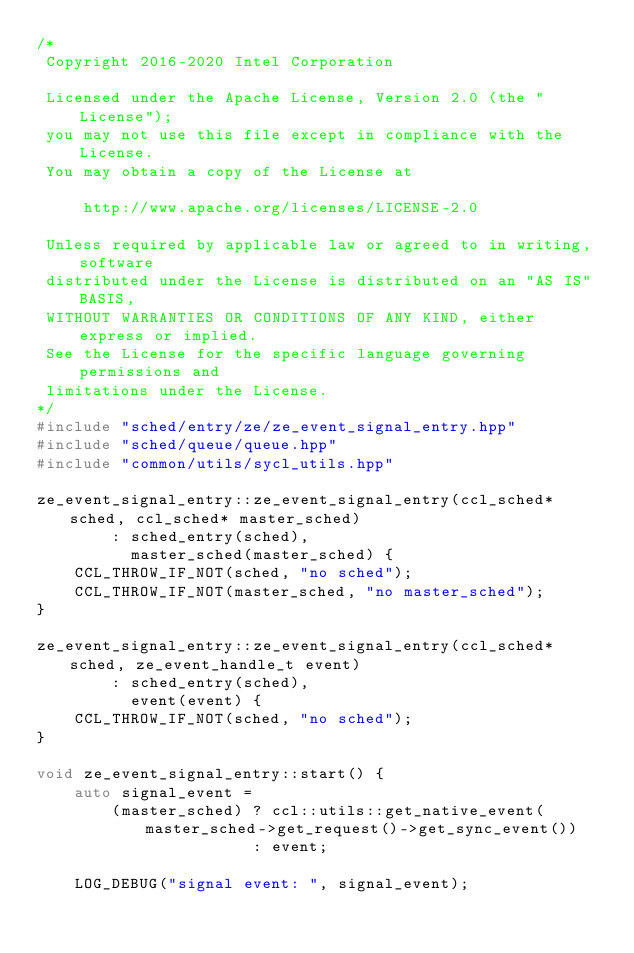Convert code to text. <code><loc_0><loc_0><loc_500><loc_500><_C++_>/*
 Copyright 2016-2020 Intel Corporation
 
 Licensed under the Apache License, Version 2.0 (the "License");
 you may not use this file except in compliance with the License.
 You may obtain a copy of the License at
 
     http://www.apache.org/licenses/LICENSE-2.0
 
 Unless required by applicable law or agreed to in writing, software
 distributed under the License is distributed on an "AS IS" BASIS,
 WITHOUT WARRANTIES OR CONDITIONS OF ANY KIND, either express or implied.
 See the License for the specific language governing permissions and
 limitations under the License.
*/
#include "sched/entry/ze/ze_event_signal_entry.hpp"
#include "sched/queue/queue.hpp"
#include "common/utils/sycl_utils.hpp"

ze_event_signal_entry::ze_event_signal_entry(ccl_sched* sched, ccl_sched* master_sched)
        : sched_entry(sched),
          master_sched(master_sched) {
    CCL_THROW_IF_NOT(sched, "no sched");
    CCL_THROW_IF_NOT(master_sched, "no master_sched");
}

ze_event_signal_entry::ze_event_signal_entry(ccl_sched* sched, ze_event_handle_t event)
        : sched_entry(sched),
          event(event) {
    CCL_THROW_IF_NOT(sched, "no sched");
}

void ze_event_signal_entry::start() {
    auto signal_event =
        (master_sched) ? ccl::utils::get_native_event(master_sched->get_request()->get_sync_event())
                       : event;

    LOG_DEBUG("signal event: ", signal_event);</code> 